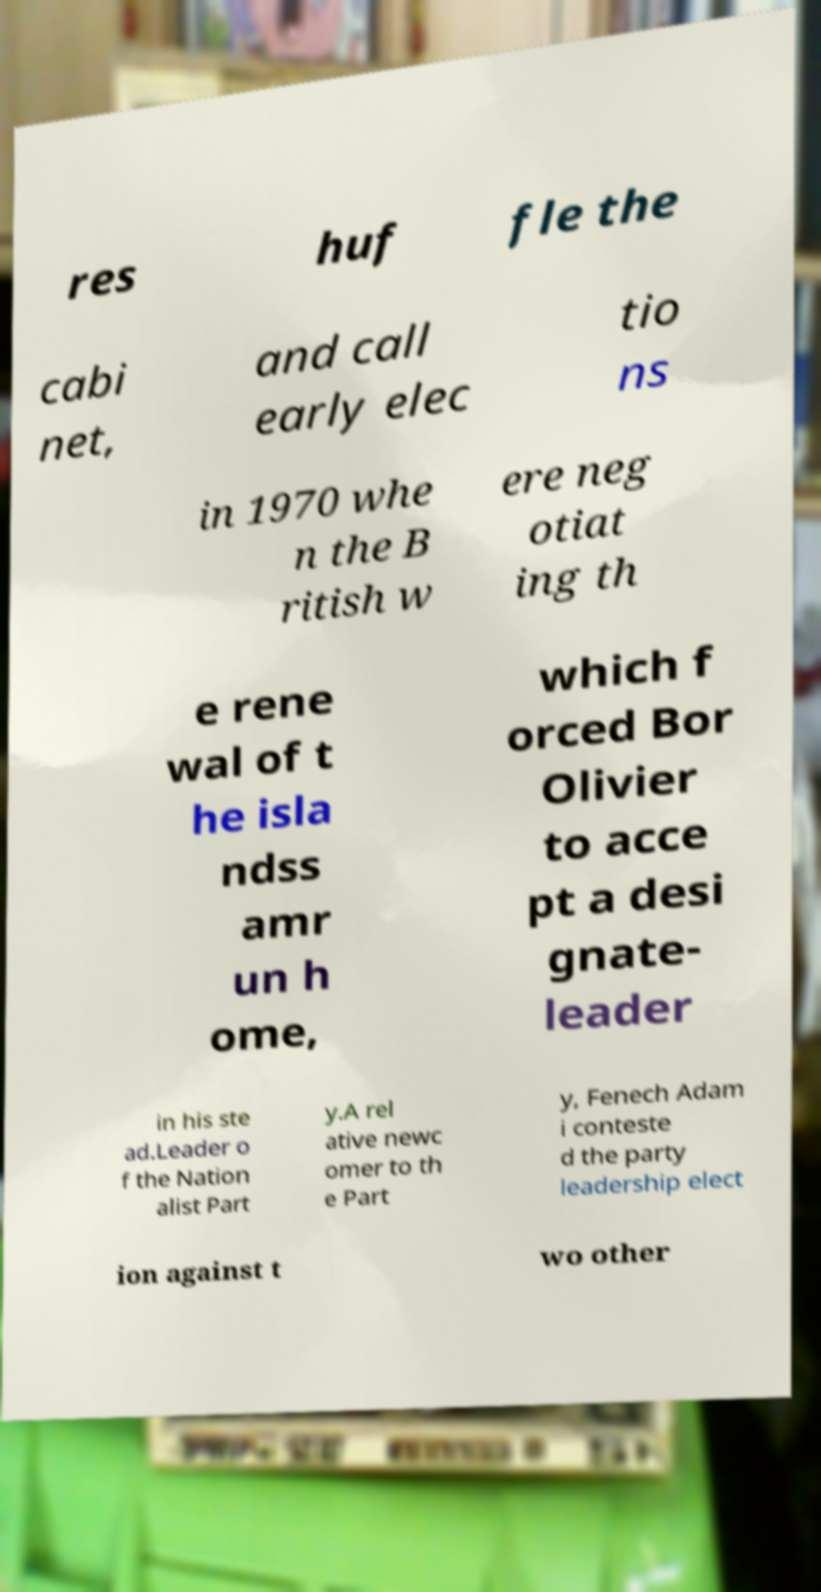I need the written content from this picture converted into text. Can you do that? res huf fle the cabi net, and call early elec tio ns in 1970 whe n the B ritish w ere neg otiat ing th e rene wal of t he isla ndss amr un h ome, which f orced Bor Olivier to acce pt a desi gnate- leader in his ste ad.Leader o f the Nation alist Part y.A rel ative newc omer to th e Part y, Fenech Adam i conteste d the party leadership elect ion against t wo other 